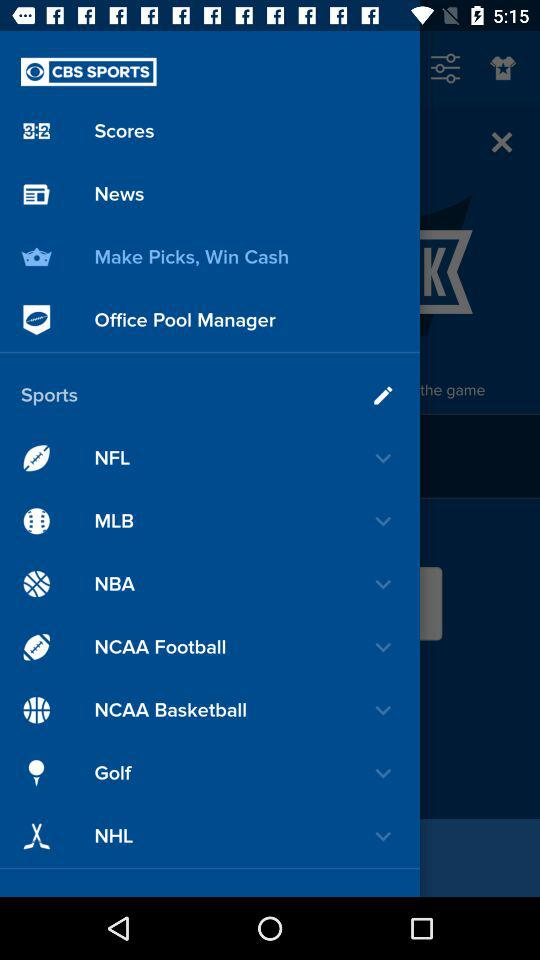Which sport is selected?
When the provided information is insufficient, respond with <no answer>. <no answer> 